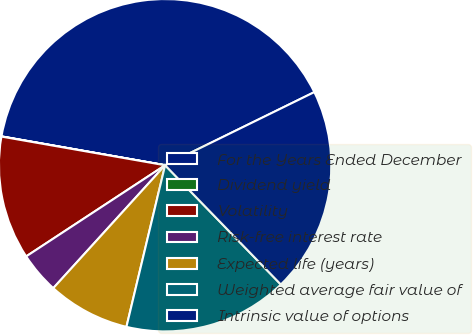Convert chart to OTSL. <chart><loc_0><loc_0><loc_500><loc_500><pie_chart><fcel>For the Years Ended December<fcel>Dividend yield<fcel>Volatility<fcel>Risk-free interest rate<fcel>Expected life (years)<fcel>Weighted average fair value of<fcel>Intrinsic value of options<nl><fcel>39.97%<fcel>0.02%<fcel>12.0%<fcel>4.01%<fcel>8.01%<fcel>16.0%<fcel>19.99%<nl></chart> 